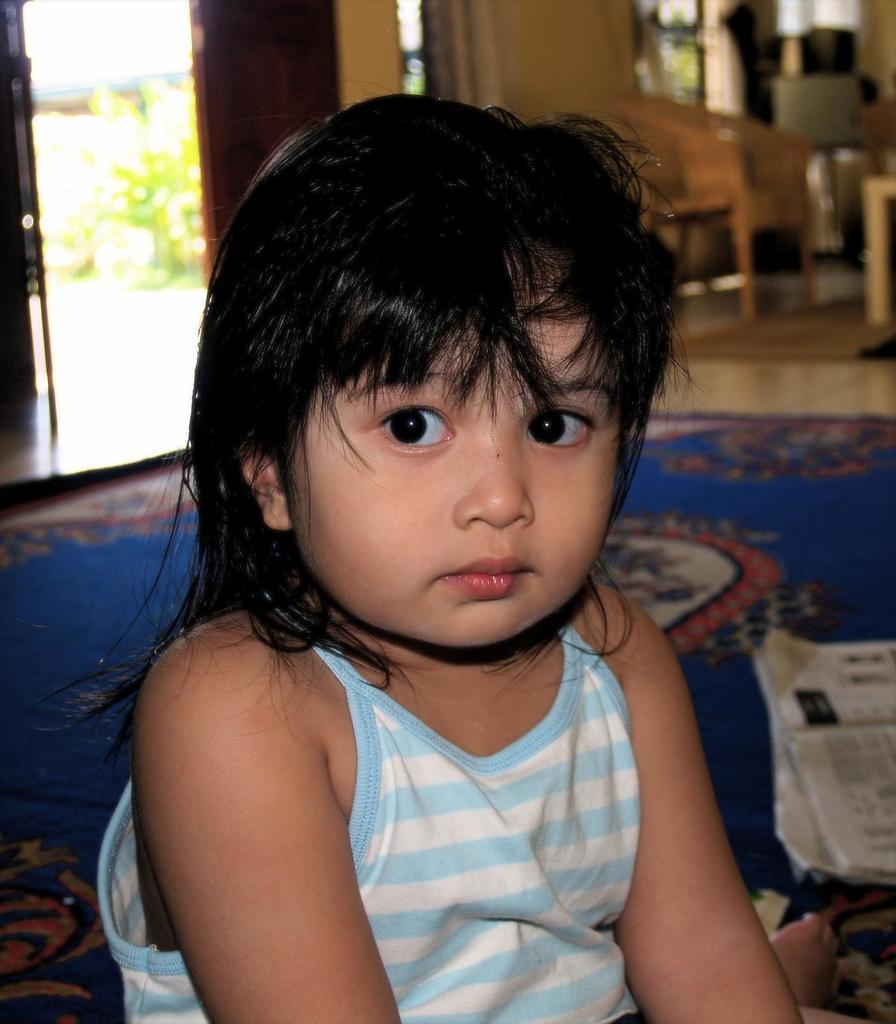Describe this image in one or two sentences. As we can see in the image in the front there is a child sitting. There is newspaper, mat, chairs, wall, door and a plant. 